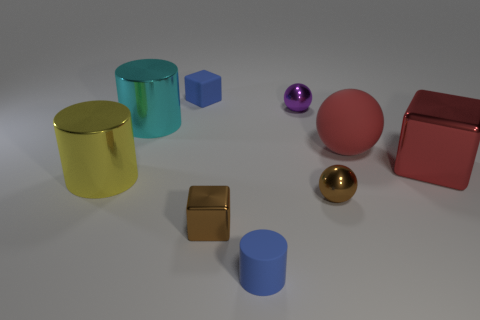Can you describe the color and shape of the object directly in the center of this image? The object in the center is a cube with a mirrored surface, reflecting a golden hue due to the surrounding objects. Its precise edges and geometrical shape stand out against the softer, rounder forms nearby. 